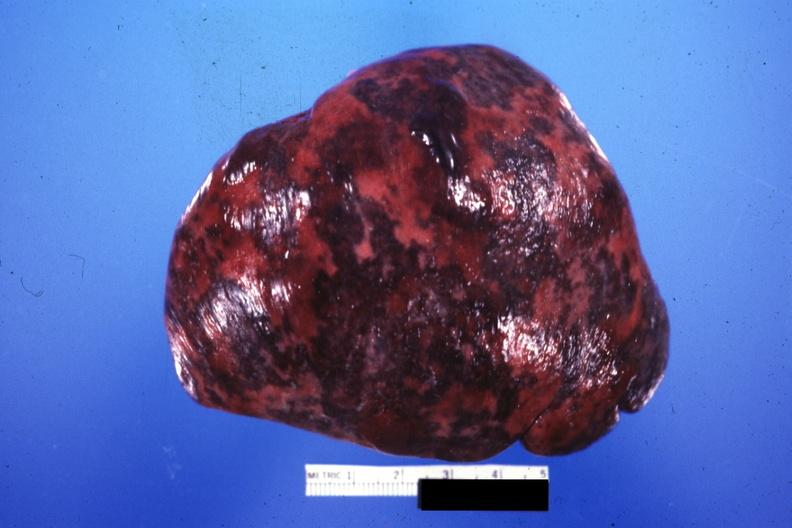s infarction secondary to shock present?
Answer the question using a single word or phrase. Yes 